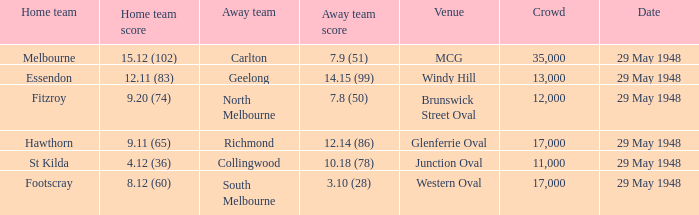In the match where north melbourne was the away team, how much did the home team score? 9.20 (74). 